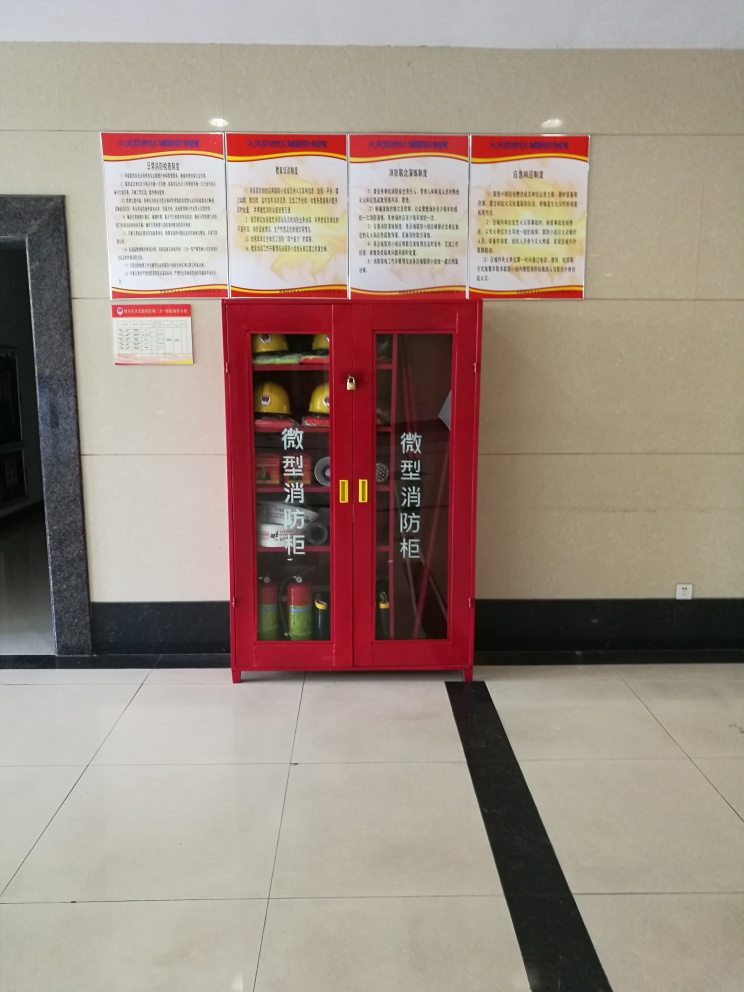Are there any quality issues with this image? While there are no overtly obvious quality issues regarding the clarity or exposure of the image, it is slightly tilted, which could be corrected for a more polished look. Additionally, the composition may benefit from cropping to improve the image's focus on the fire safety equipment cabinet and its surrounding information signs. 